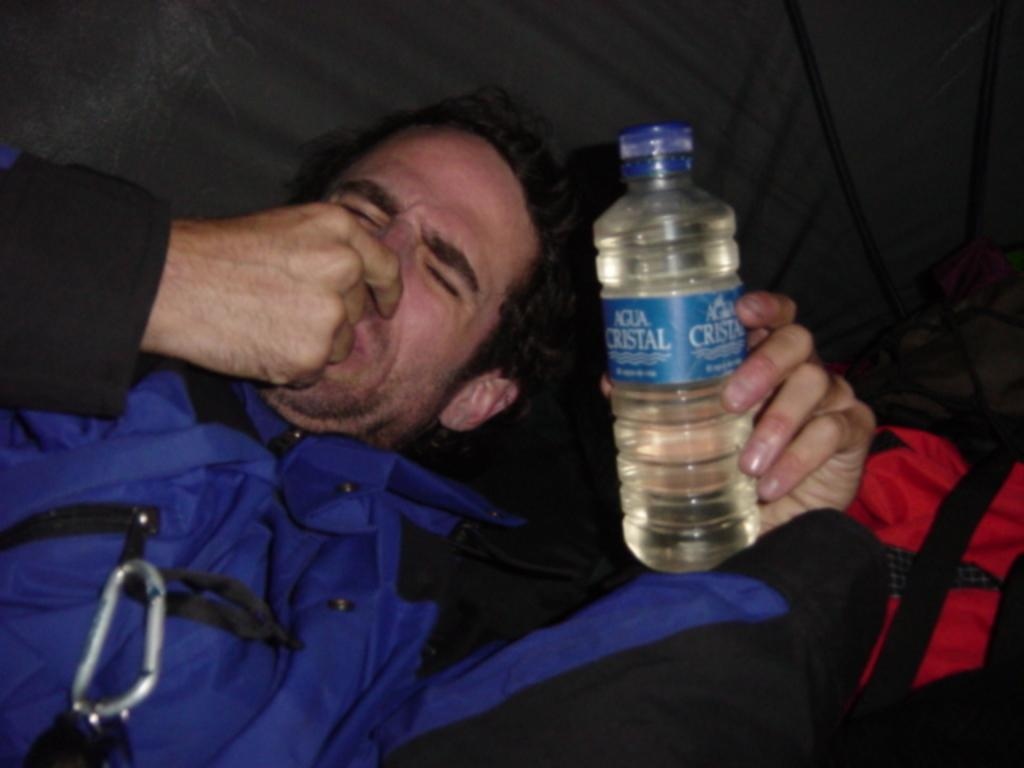Who is present in the image? There is a man in the image. What is the man doing in the image? The man is laying on a couch. What object is the man holding in the image? The man is holding a water bottle. What can be seen in the background of the image? There is a bag in the background of the image. What type of grape can be seen in the man's hand in the image? There is no grape present in the image; the man is holding a water bottle. How does the man's laughter sound in the image? There is no indication of laughter in the image; the man is laying on a couch and holding a water bottle. 